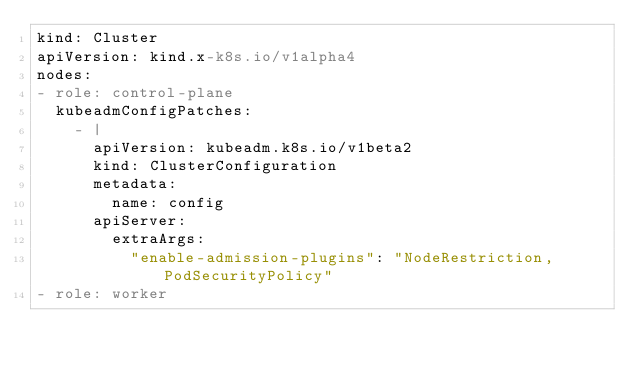Convert code to text. <code><loc_0><loc_0><loc_500><loc_500><_YAML_>kind: Cluster
apiVersion: kind.x-k8s.io/v1alpha4
nodes:
- role: control-plane
  kubeadmConfigPatches:
    - |
      apiVersion: kubeadm.k8s.io/v1beta2
      kind: ClusterConfiguration
      metadata:
        name: config
      apiServer:
        extraArgs:
          "enable-admission-plugins": "NodeRestriction,PodSecurityPolicy"
- role: worker</code> 